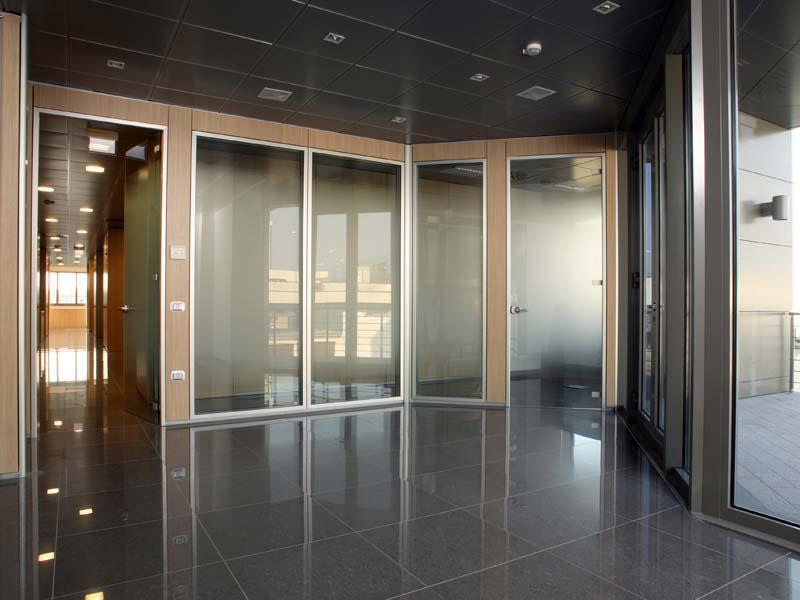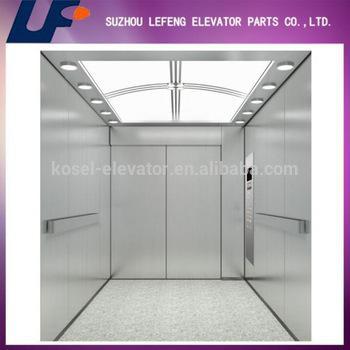The first image is the image on the left, the second image is the image on the right. For the images displayed, is the sentence "In at least one image there is a sliver elevator and the other image is ofwhite frame glass windows." factually correct? Answer yes or no. Yes. The first image is the image on the left, the second image is the image on the right. For the images shown, is this caption "One image features silver elevator doors, and the other image features glass windows that reach nearly to the ceiling." true? Answer yes or no. Yes. 